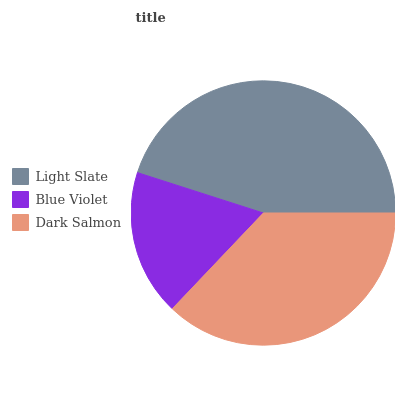Is Blue Violet the minimum?
Answer yes or no. Yes. Is Light Slate the maximum?
Answer yes or no. Yes. Is Dark Salmon the minimum?
Answer yes or no. No. Is Dark Salmon the maximum?
Answer yes or no. No. Is Dark Salmon greater than Blue Violet?
Answer yes or no. Yes. Is Blue Violet less than Dark Salmon?
Answer yes or no. Yes. Is Blue Violet greater than Dark Salmon?
Answer yes or no. No. Is Dark Salmon less than Blue Violet?
Answer yes or no. No. Is Dark Salmon the high median?
Answer yes or no. Yes. Is Dark Salmon the low median?
Answer yes or no. Yes. Is Blue Violet the high median?
Answer yes or no. No. Is Blue Violet the low median?
Answer yes or no. No. 